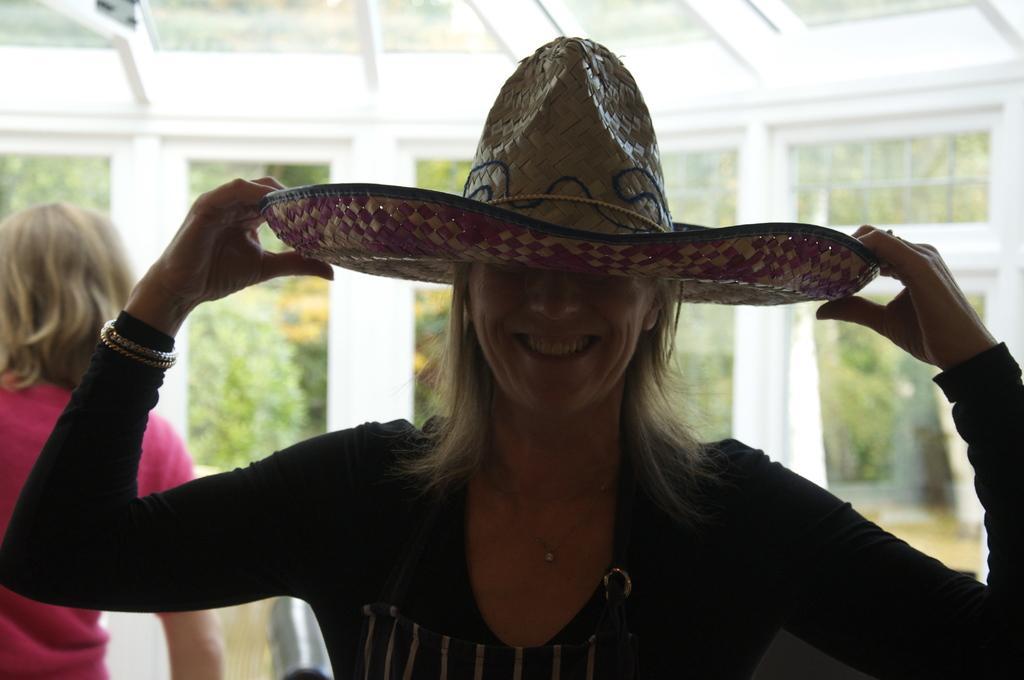In one or two sentences, can you explain what this image depicts? In this picture we can see a woman holding a hat and behind the woman there is another woman and glass windows. Behind the windows there are trees. 